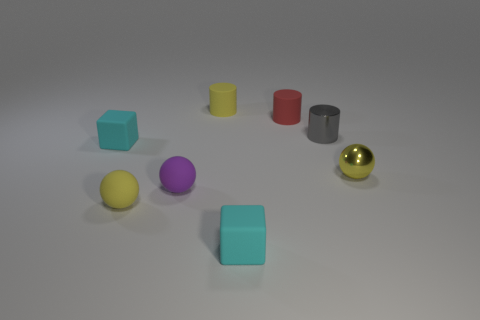What number of yellow matte spheres have the same size as the yellow cylinder?
Ensure brevity in your answer.  1. Does the small rubber object that is left of the yellow matte ball have the same shape as the tiny yellow object that is behind the gray cylinder?
Keep it short and to the point. No. The small sphere on the right side of the matte cylinder that is behind the small red matte object is what color?
Your answer should be compact. Yellow. What is the color of the other rubber thing that is the same shape as the small red thing?
Ensure brevity in your answer.  Yellow. What is the size of the red matte object that is the same shape as the small gray object?
Provide a succinct answer. Small. What material is the yellow object that is to the right of the small red matte cylinder?
Keep it short and to the point. Metal. Is the number of yellow balls that are on the right side of the small gray thing less than the number of green matte objects?
Give a very brief answer. No. The tiny yellow matte object in front of the small cylinder that is in front of the small red rubber thing is what shape?
Make the answer very short. Sphere. The small metal ball is what color?
Offer a very short reply. Yellow. How many other objects are the same size as the purple rubber sphere?
Your answer should be very brief. 7. 